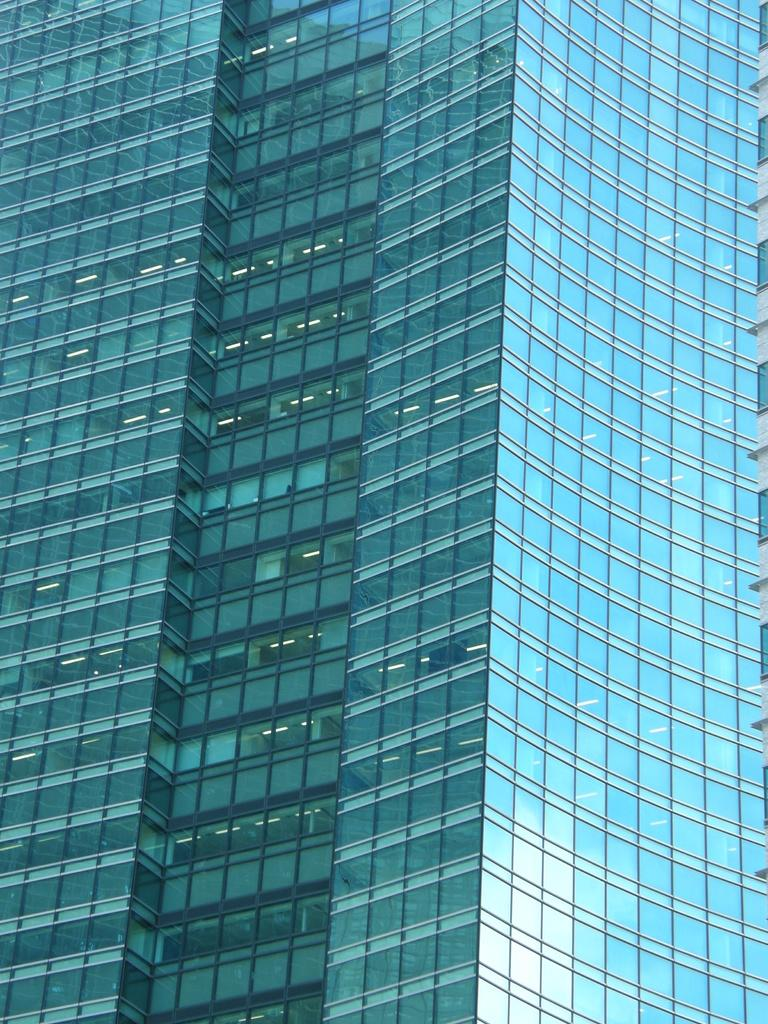What type of structure is visible in the image? There is a building in the image. How many snakes are crawling on the building in the image? There are no snakes visible in the image; it only shows a building. What type of flowers can be seen growing on the building in the image? There are no flowers present on the building in the image. 